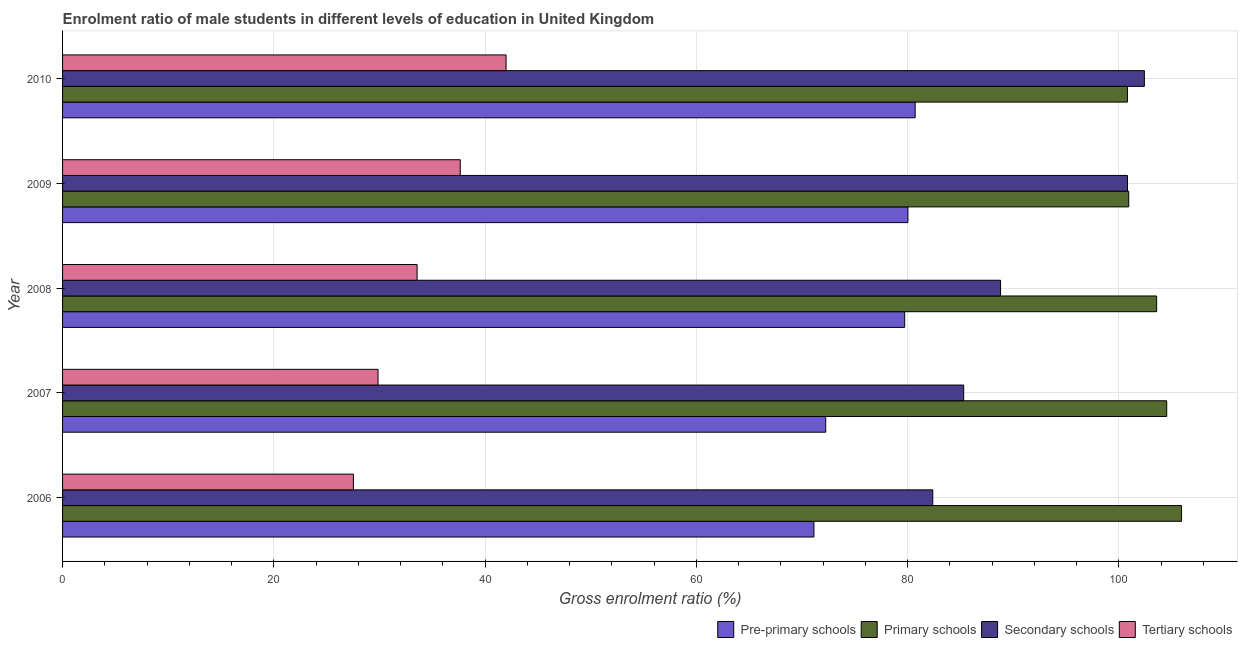How many bars are there on the 1st tick from the bottom?
Your answer should be compact. 4. What is the label of the 2nd group of bars from the top?
Make the answer very short. 2009. In how many cases, is the number of bars for a given year not equal to the number of legend labels?
Provide a succinct answer. 0. What is the gross enrolment ratio(female) in primary schools in 2008?
Your answer should be very brief. 103.57. Across all years, what is the maximum gross enrolment ratio(female) in tertiary schools?
Your answer should be very brief. 41.98. Across all years, what is the minimum gross enrolment ratio(female) in tertiary schools?
Provide a short and direct response. 27.53. In which year was the gross enrolment ratio(female) in primary schools maximum?
Provide a succinct answer. 2006. In which year was the gross enrolment ratio(female) in primary schools minimum?
Provide a short and direct response. 2010. What is the total gross enrolment ratio(female) in primary schools in the graph?
Your response must be concise. 515.78. What is the difference between the gross enrolment ratio(female) in secondary schools in 2008 and that in 2010?
Provide a succinct answer. -13.61. What is the difference between the gross enrolment ratio(female) in tertiary schools in 2010 and the gross enrolment ratio(female) in pre-primary schools in 2009?
Offer a terse response. -38.05. What is the average gross enrolment ratio(female) in tertiary schools per year?
Ensure brevity in your answer.  34.12. In the year 2010, what is the difference between the gross enrolment ratio(female) in secondary schools and gross enrolment ratio(female) in primary schools?
Provide a succinct answer. 1.6. In how many years, is the gross enrolment ratio(female) in pre-primary schools greater than 16 %?
Give a very brief answer. 5. What is the ratio of the gross enrolment ratio(female) in pre-primary schools in 2007 to that in 2010?
Provide a succinct answer. 0.9. Is the gross enrolment ratio(female) in secondary schools in 2006 less than that in 2008?
Your response must be concise. Yes. What is the difference between the highest and the second highest gross enrolment ratio(female) in primary schools?
Offer a very short reply. 1.41. What is the difference between the highest and the lowest gross enrolment ratio(female) in tertiary schools?
Your response must be concise. 14.45. Is it the case that in every year, the sum of the gross enrolment ratio(female) in secondary schools and gross enrolment ratio(female) in pre-primary schools is greater than the sum of gross enrolment ratio(female) in tertiary schools and gross enrolment ratio(female) in primary schools?
Your answer should be compact. No. What does the 3rd bar from the top in 2010 represents?
Give a very brief answer. Primary schools. What does the 3rd bar from the bottom in 2009 represents?
Offer a very short reply. Secondary schools. Is it the case that in every year, the sum of the gross enrolment ratio(female) in pre-primary schools and gross enrolment ratio(female) in primary schools is greater than the gross enrolment ratio(female) in secondary schools?
Provide a short and direct response. Yes. How many bars are there?
Provide a succinct answer. 20. Are all the bars in the graph horizontal?
Ensure brevity in your answer.  Yes. What is the difference between two consecutive major ticks on the X-axis?
Your answer should be compact. 20. Does the graph contain any zero values?
Keep it short and to the point. No. Does the graph contain grids?
Offer a very short reply. Yes. How many legend labels are there?
Offer a terse response. 4. What is the title of the graph?
Give a very brief answer. Enrolment ratio of male students in different levels of education in United Kingdom. What is the label or title of the Y-axis?
Offer a terse response. Year. What is the Gross enrolment ratio (%) of Pre-primary schools in 2006?
Your answer should be compact. 71.13. What is the Gross enrolment ratio (%) of Primary schools in 2006?
Keep it short and to the point. 105.93. What is the Gross enrolment ratio (%) in Secondary schools in 2006?
Keep it short and to the point. 82.38. What is the Gross enrolment ratio (%) of Tertiary schools in 2006?
Your response must be concise. 27.53. What is the Gross enrolment ratio (%) of Pre-primary schools in 2007?
Offer a very short reply. 72.25. What is the Gross enrolment ratio (%) of Primary schools in 2007?
Your response must be concise. 104.53. What is the Gross enrolment ratio (%) in Secondary schools in 2007?
Your response must be concise. 85.31. What is the Gross enrolment ratio (%) of Tertiary schools in 2007?
Offer a terse response. 29.87. What is the Gross enrolment ratio (%) in Pre-primary schools in 2008?
Make the answer very short. 79.72. What is the Gross enrolment ratio (%) in Primary schools in 2008?
Provide a short and direct response. 103.57. What is the Gross enrolment ratio (%) in Secondary schools in 2008?
Your response must be concise. 88.8. What is the Gross enrolment ratio (%) of Tertiary schools in 2008?
Your answer should be compact. 33.56. What is the Gross enrolment ratio (%) of Pre-primary schools in 2009?
Give a very brief answer. 80.03. What is the Gross enrolment ratio (%) of Primary schools in 2009?
Provide a short and direct response. 100.93. What is the Gross enrolment ratio (%) of Secondary schools in 2009?
Offer a very short reply. 100.82. What is the Gross enrolment ratio (%) in Tertiary schools in 2009?
Offer a very short reply. 37.65. What is the Gross enrolment ratio (%) of Pre-primary schools in 2010?
Ensure brevity in your answer.  80.71. What is the Gross enrolment ratio (%) in Primary schools in 2010?
Provide a short and direct response. 100.81. What is the Gross enrolment ratio (%) in Secondary schools in 2010?
Give a very brief answer. 102.41. What is the Gross enrolment ratio (%) in Tertiary schools in 2010?
Make the answer very short. 41.98. Across all years, what is the maximum Gross enrolment ratio (%) of Pre-primary schools?
Offer a terse response. 80.71. Across all years, what is the maximum Gross enrolment ratio (%) of Primary schools?
Give a very brief answer. 105.93. Across all years, what is the maximum Gross enrolment ratio (%) in Secondary schools?
Offer a very short reply. 102.41. Across all years, what is the maximum Gross enrolment ratio (%) of Tertiary schools?
Provide a succinct answer. 41.98. Across all years, what is the minimum Gross enrolment ratio (%) in Pre-primary schools?
Provide a short and direct response. 71.13. Across all years, what is the minimum Gross enrolment ratio (%) in Primary schools?
Your answer should be compact. 100.81. Across all years, what is the minimum Gross enrolment ratio (%) in Secondary schools?
Provide a short and direct response. 82.38. Across all years, what is the minimum Gross enrolment ratio (%) of Tertiary schools?
Your answer should be compact. 27.53. What is the total Gross enrolment ratio (%) in Pre-primary schools in the graph?
Your response must be concise. 383.84. What is the total Gross enrolment ratio (%) in Primary schools in the graph?
Ensure brevity in your answer.  515.78. What is the total Gross enrolment ratio (%) of Secondary schools in the graph?
Provide a succinct answer. 459.72. What is the total Gross enrolment ratio (%) in Tertiary schools in the graph?
Make the answer very short. 170.59. What is the difference between the Gross enrolment ratio (%) in Pre-primary schools in 2006 and that in 2007?
Your answer should be compact. -1.11. What is the difference between the Gross enrolment ratio (%) in Primary schools in 2006 and that in 2007?
Provide a short and direct response. 1.41. What is the difference between the Gross enrolment ratio (%) in Secondary schools in 2006 and that in 2007?
Your answer should be very brief. -2.93. What is the difference between the Gross enrolment ratio (%) of Tertiary schools in 2006 and that in 2007?
Keep it short and to the point. -2.33. What is the difference between the Gross enrolment ratio (%) of Pre-primary schools in 2006 and that in 2008?
Offer a very short reply. -8.59. What is the difference between the Gross enrolment ratio (%) in Primary schools in 2006 and that in 2008?
Ensure brevity in your answer.  2.36. What is the difference between the Gross enrolment ratio (%) of Secondary schools in 2006 and that in 2008?
Provide a succinct answer. -6.42. What is the difference between the Gross enrolment ratio (%) of Tertiary schools in 2006 and that in 2008?
Your answer should be very brief. -6.03. What is the difference between the Gross enrolment ratio (%) in Pre-primary schools in 2006 and that in 2009?
Offer a very short reply. -8.9. What is the difference between the Gross enrolment ratio (%) of Primary schools in 2006 and that in 2009?
Offer a very short reply. 5. What is the difference between the Gross enrolment ratio (%) of Secondary schools in 2006 and that in 2009?
Give a very brief answer. -18.43. What is the difference between the Gross enrolment ratio (%) of Tertiary schools in 2006 and that in 2009?
Ensure brevity in your answer.  -10.12. What is the difference between the Gross enrolment ratio (%) in Pre-primary schools in 2006 and that in 2010?
Give a very brief answer. -9.58. What is the difference between the Gross enrolment ratio (%) in Primary schools in 2006 and that in 2010?
Provide a short and direct response. 5.12. What is the difference between the Gross enrolment ratio (%) of Secondary schools in 2006 and that in 2010?
Your answer should be very brief. -20.03. What is the difference between the Gross enrolment ratio (%) of Tertiary schools in 2006 and that in 2010?
Your answer should be very brief. -14.45. What is the difference between the Gross enrolment ratio (%) of Pre-primary schools in 2007 and that in 2008?
Provide a succinct answer. -7.48. What is the difference between the Gross enrolment ratio (%) of Primary schools in 2007 and that in 2008?
Ensure brevity in your answer.  0.95. What is the difference between the Gross enrolment ratio (%) of Secondary schools in 2007 and that in 2008?
Your answer should be compact. -3.49. What is the difference between the Gross enrolment ratio (%) of Tertiary schools in 2007 and that in 2008?
Your response must be concise. -3.7. What is the difference between the Gross enrolment ratio (%) of Pre-primary schools in 2007 and that in 2009?
Your answer should be compact. -7.79. What is the difference between the Gross enrolment ratio (%) of Primary schools in 2007 and that in 2009?
Ensure brevity in your answer.  3.59. What is the difference between the Gross enrolment ratio (%) of Secondary schools in 2007 and that in 2009?
Ensure brevity in your answer.  -15.51. What is the difference between the Gross enrolment ratio (%) of Tertiary schools in 2007 and that in 2009?
Make the answer very short. -7.78. What is the difference between the Gross enrolment ratio (%) of Pre-primary schools in 2007 and that in 2010?
Give a very brief answer. -8.47. What is the difference between the Gross enrolment ratio (%) of Primary schools in 2007 and that in 2010?
Provide a short and direct response. 3.72. What is the difference between the Gross enrolment ratio (%) of Secondary schools in 2007 and that in 2010?
Offer a terse response. -17.11. What is the difference between the Gross enrolment ratio (%) in Tertiary schools in 2007 and that in 2010?
Your response must be concise. -12.12. What is the difference between the Gross enrolment ratio (%) in Pre-primary schools in 2008 and that in 2009?
Your answer should be very brief. -0.31. What is the difference between the Gross enrolment ratio (%) of Primary schools in 2008 and that in 2009?
Provide a succinct answer. 2.64. What is the difference between the Gross enrolment ratio (%) of Secondary schools in 2008 and that in 2009?
Offer a terse response. -12.02. What is the difference between the Gross enrolment ratio (%) in Tertiary schools in 2008 and that in 2009?
Your answer should be compact. -4.08. What is the difference between the Gross enrolment ratio (%) of Pre-primary schools in 2008 and that in 2010?
Make the answer very short. -0.99. What is the difference between the Gross enrolment ratio (%) in Primary schools in 2008 and that in 2010?
Your answer should be compact. 2.77. What is the difference between the Gross enrolment ratio (%) of Secondary schools in 2008 and that in 2010?
Offer a very short reply. -13.61. What is the difference between the Gross enrolment ratio (%) in Tertiary schools in 2008 and that in 2010?
Offer a very short reply. -8.42. What is the difference between the Gross enrolment ratio (%) of Pre-primary schools in 2009 and that in 2010?
Offer a terse response. -0.68. What is the difference between the Gross enrolment ratio (%) of Primary schools in 2009 and that in 2010?
Make the answer very short. 0.13. What is the difference between the Gross enrolment ratio (%) in Secondary schools in 2009 and that in 2010?
Offer a terse response. -1.6. What is the difference between the Gross enrolment ratio (%) in Tertiary schools in 2009 and that in 2010?
Offer a terse response. -4.34. What is the difference between the Gross enrolment ratio (%) in Pre-primary schools in 2006 and the Gross enrolment ratio (%) in Primary schools in 2007?
Make the answer very short. -33.4. What is the difference between the Gross enrolment ratio (%) in Pre-primary schools in 2006 and the Gross enrolment ratio (%) in Secondary schools in 2007?
Provide a short and direct response. -14.18. What is the difference between the Gross enrolment ratio (%) in Pre-primary schools in 2006 and the Gross enrolment ratio (%) in Tertiary schools in 2007?
Ensure brevity in your answer.  41.27. What is the difference between the Gross enrolment ratio (%) of Primary schools in 2006 and the Gross enrolment ratio (%) of Secondary schools in 2007?
Your answer should be very brief. 20.62. What is the difference between the Gross enrolment ratio (%) in Primary schools in 2006 and the Gross enrolment ratio (%) in Tertiary schools in 2007?
Offer a very short reply. 76.07. What is the difference between the Gross enrolment ratio (%) in Secondary schools in 2006 and the Gross enrolment ratio (%) in Tertiary schools in 2007?
Your answer should be compact. 52.52. What is the difference between the Gross enrolment ratio (%) of Pre-primary schools in 2006 and the Gross enrolment ratio (%) of Primary schools in 2008?
Make the answer very short. -32.44. What is the difference between the Gross enrolment ratio (%) in Pre-primary schools in 2006 and the Gross enrolment ratio (%) in Secondary schools in 2008?
Give a very brief answer. -17.67. What is the difference between the Gross enrolment ratio (%) in Pre-primary schools in 2006 and the Gross enrolment ratio (%) in Tertiary schools in 2008?
Your response must be concise. 37.57. What is the difference between the Gross enrolment ratio (%) in Primary schools in 2006 and the Gross enrolment ratio (%) in Secondary schools in 2008?
Your answer should be very brief. 17.13. What is the difference between the Gross enrolment ratio (%) in Primary schools in 2006 and the Gross enrolment ratio (%) in Tertiary schools in 2008?
Provide a short and direct response. 72.37. What is the difference between the Gross enrolment ratio (%) of Secondary schools in 2006 and the Gross enrolment ratio (%) of Tertiary schools in 2008?
Keep it short and to the point. 48.82. What is the difference between the Gross enrolment ratio (%) of Pre-primary schools in 2006 and the Gross enrolment ratio (%) of Primary schools in 2009?
Offer a terse response. -29.8. What is the difference between the Gross enrolment ratio (%) in Pre-primary schools in 2006 and the Gross enrolment ratio (%) in Secondary schools in 2009?
Offer a very short reply. -29.68. What is the difference between the Gross enrolment ratio (%) of Pre-primary schools in 2006 and the Gross enrolment ratio (%) of Tertiary schools in 2009?
Offer a terse response. 33.48. What is the difference between the Gross enrolment ratio (%) in Primary schools in 2006 and the Gross enrolment ratio (%) in Secondary schools in 2009?
Your answer should be very brief. 5.12. What is the difference between the Gross enrolment ratio (%) in Primary schools in 2006 and the Gross enrolment ratio (%) in Tertiary schools in 2009?
Give a very brief answer. 68.28. What is the difference between the Gross enrolment ratio (%) in Secondary schools in 2006 and the Gross enrolment ratio (%) in Tertiary schools in 2009?
Make the answer very short. 44.73. What is the difference between the Gross enrolment ratio (%) of Pre-primary schools in 2006 and the Gross enrolment ratio (%) of Primary schools in 2010?
Give a very brief answer. -29.68. What is the difference between the Gross enrolment ratio (%) in Pre-primary schools in 2006 and the Gross enrolment ratio (%) in Secondary schools in 2010?
Your answer should be very brief. -31.28. What is the difference between the Gross enrolment ratio (%) of Pre-primary schools in 2006 and the Gross enrolment ratio (%) of Tertiary schools in 2010?
Give a very brief answer. 29.15. What is the difference between the Gross enrolment ratio (%) of Primary schools in 2006 and the Gross enrolment ratio (%) of Secondary schools in 2010?
Provide a short and direct response. 3.52. What is the difference between the Gross enrolment ratio (%) in Primary schools in 2006 and the Gross enrolment ratio (%) in Tertiary schools in 2010?
Make the answer very short. 63.95. What is the difference between the Gross enrolment ratio (%) in Secondary schools in 2006 and the Gross enrolment ratio (%) in Tertiary schools in 2010?
Make the answer very short. 40.4. What is the difference between the Gross enrolment ratio (%) of Pre-primary schools in 2007 and the Gross enrolment ratio (%) of Primary schools in 2008?
Your answer should be very brief. -31.33. What is the difference between the Gross enrolment ratio (%) in Pre-primary schools in 2007 and the Gross enrolment ratio (%) in Secondary schools in 2008?
Make the answer very short. -16.55. What is the difference between the Gross enrolment ratio (%) of Pre-primary schools in 2007 and the Gross enrolment ratio (%) of Tertiary schools in 2008?
Give a very brief answer. 38.68. What is the difference between the Gross enrolment ratio (%) of Primary schools in 2007 and the Gross enrolment ratio (%) of Secondary schools in 2008?
Your answer should be very brief. 15.73. What is the difference between the Gross enrolment ratio (%) of Primary schools in 2007 and the Gross enrolment ratio (%) of Tertiary schools in 2008?
Offer a very short reply. 70.96. What is the difference between the Gross enrolment ratio (%) in Secondary schools in 2007 and the Gross enrolment ratio (%) in Tertiary schools in 2008?
Provide a succinct answer. 51.75. What is the difference between the Gross enrolment ratio (%) in Pre-primary schools in 2007 and the Gross enrolment ratio (%) in Primary schools in 2009?
Your answer should be compact. -28.69. What is the difference between the Gross enrolment ratio (%) in Pre-primary schools in 2007 and the Gross enrolment ratio (%) in Secondary schools in 2009?
Ensure brevity in your answer.  -28.57. What is the difference between the Gross enrolment ratio (%) in Pre-primary schools in 2007 and the Gross enrolment ratio (%) in Tertiary schools in 2009?
Provide a succinct answer. 34.6. What is the difference between the Gross enrolment ratio (%) in Primary schools in 2007 and the Gross enrolment ratio (%) in Secondary schools in 2009?
Your response must be concise. 3.71. What is the difference between the Gross enrolment ratio (%) of Primary schools in 2007 and the Gross enrolment ratio (%) of Tertiary schools in 2009?
Ensure brevity in your answer.  66.88. What is the difference between the Gross enrolment ratio (%) of Secondary schools in 2007 and the Gross enrolment ratio (%) of Tertiary schools in 2009?
Offer a very short reply. 47.66. What is the difference between the Gross enrolment ratio (%) of Pre-primary schools in 2007 and the Gross enrolment ratio (%) of Primary schools in 2010?
Make the answer very short. -28.56. What is the difference between the Gross enrolment ratio (%) in Pre-primary schools in 2007 and the Gross enrolment ratio (%) in Secondary schools in 2010?
Ensure brevity in your answer.  -30.17. What is the difference between the Gross enrolment ratio (%) in Pre-primary schools in 2007 and the Gross enrolment ratio (%) in Tertiary schools in 2010?
Keep it short and to the point. 30.26. What is the difference between the Gross enrolment ratio (%) of Primary schools in 2007 and the Gross enrolment ratio (%) of Secondary schools in 2010?
Keep it short and to the point. 2.11. What is the difference between the Gross enrolment ratio (%) of Primary schools in 2007 and the Gross enrolment ratio (%) of Tertiary schools in 2010?
Offer a very short reply. 62.54. What is the difference between the Gross enrolment ratio (%) in Secondary schools in 2007 and the Gross enrolment ratio (%) in Tertiary schools in 2010?
Your answer should be compact. 43.32. What is the difference between the Gross enrolment ratio (%) in Pre-primary schools in 2008 and the Gross enrolment ratio (%) in Primary schools in 2009?
Provide a succinct answer. -21.21. What is the difference between the Gross enrolment ratio (%) in Pre-primary schools in 2008 and the Gross enrolment ratio (%) in Secondary schools in 2009?
Ensure brevity in your answer.  -21.09. What is the difference between the Gross enrolment ratio (%) of Pre-primary schools in 2008 and the Gross enrolment ratio (%) of Tertiary schools in 2009?
Keep it short and to the point. 42.07. What is the difference between the Gross enrolment ratio (%) in Primary schools in 2008 and the Gross enrolment ratio (%) in Secondary schools in 2009?
Offer a terse response. 2.76. What is the difference between the Gross enrolment ratio (%) of Primary schools in 2008 and the Gross enrolment ratio (%) of Tertiary schools in 2009?
Ensure brevity in your answer.  65.93. What is the difference between the Gross enrolment ratio (%) of Secondary schools in 2008 and the Gross enrolment ratio (%) of Tertiary schools in 2009?
Your answer should be very brief. 51.15. What is the difference between the Gross enrolment ratio (%) in Pre-primary schools in 2008 and the Gross enrolment ratio (%) in Primary schools in 2010?
Keep it short and to the point. -21.09. What is the difference between the Gross enrolment ratio (%) of Pre-primary schools in 2008 and the Gross enrolment ratio (%) of Secondary schools in 2010?
Keep it short and to the point. -22.69. What is the difference between the Gross enrolment ratio (%) of Pre-primary schools in 2008 and the Gross enrolment ratio (%) of Tertiary schools in 2010?
Provide a succinct answer. 37.74. What is the difference between the Gross enrolment ratio (%) in Primary schools in 2008 and the Gross enrolment ratio (%) in Secondary schools in 2010?
Provide a succinct answer. 1.16. What is the difference between the Gross enrolment ratio (%) in Primary schools in 2008 and the Gross enrolment ratio (%) in Tertiary schools in 2010?
Keep it short and to the point. 61.59. What is the difference between the Gross enrolment ratio (%) of Secondary schools in 2008 and the Gross enrolment ratio (%) of Tertiary schools in 2010?
Ensure brevity in your answer.  46.81. What is the difference between the Gross enrolment ratio (%) in Pre-primary schools in 2009 and the Gross enrolment ratio (%) in Primary schools in 2010?
Your answer should be very brief. -20.78. What is the difference between the Gross enrolment ratio (%) in Pre-primary schools in 2009 and the Gross enrolment ratio (%) in Secondary schools in 2010?
Provide a short and direct response. -22.38. What is the difference between the Gross enrolment ratio (%) of Pre-primary schools in 2009 and the Gross enrolment ratio (%) of Tertiary schools in 2010?
Your answer should be very brief. 38.05. What is the difference between the Gross enrolment ratio (%) in Primary schools in 2009 and the Gross enrolment ratio (%) in Secondary schools in 2010?
Ensure brevity in your answer.  -1.48. What is the difference between the Gross enrolment ratio (%) of Primary schools in 2009 and the Gross enrolment ratio (%) of Tertiary schools in 2010?
Offer a terse response. 58.95. What is the difference between the Gross enrolment ratio (%) in Secondary schools in 2009 and the Gross enrolment ratio (%) in Tertiary schools in 2010?
Offer a terse response. 58.83. What is the average Gross enrolment ratio (%) in Pre-primary schools per year?
Your response must be concise. 76.77. What is the average Gross enrolment ratio (%) of Primary schools per year?
Make the answer very short. 103.16. What is the average Gross enrolment ratio (%) of Secondary schools per year?
Make the answer very short. 91.94. What is the average Gross enrolment ratio (%) in Tertiary schools per year?
Provide a short and direct response. 34.12. In the year 2006, what is the difference between the Gross enrolment ratio (%) in Pre-primary schools and Gross enrolment ratio (%) in Primary schools?
Keep it short and to the point. -34.8. In the year 2006, what is the difference between the Gross enrolment ratio (%) of Pre-primary schools and Gross enrolment ratio (%) of Secondary schools?
Give a very brief answer. -11.25. In the year 2006, what is the difference between the Gross enrolment ratio (%) of Pre-primary schools and Gross enrolment ratio (%) of Tertiary schools?
Offer a terse response. 43.6. In the year 2006, what is the difference between the Gross enrolment ratio (%) in Primary schools and Gross enrolment ratio (%) in Secondary schools?
Keep it short and to the point. 23.55. In the year 2006, what is the difference between the Gross enrolment ratio (%) of Primary schools and Gross enrolment ratio (%) of Tertiary schools?
Make the answer very short. 78.4. In the year 2006, what is the difference between the Gross enrolment ratio (%) in Secondary schools and Gross enrolment ratio (%) in Tertiary schools?
Keep it short and to the point. 54.85. In the year 2007, what is the difference between the Gross enrolment ratio (%) in Pre-primary schools and Gross enrolment ratio (%) in Primary schools?
Keep it short and to the point. -32.28. In the year 2007, what is the difference between the Gross enrolment ratio (%) of Pre-primary schools and Gross enrolment ratio (%) of Secondary schools?
Offer a very short reply. -13.06. In the year 2007, what is the difference between the Gross enrolment ratio (%) of Pre-primary schools and Gross enrolment ratio (%) of Tertiary schools?
Keep it short and to the point. 42.38. In the year 2007, what is the difference between the Gross enrolment ratio (%) of Primary schools and Gross enrolment ratio (%) of Secondary schools?
Offer a terse response. 19.22. In the year 2007, what is the difference between the Gross enrolment ratio (%) of Primary schools and Gross enrolment ratio (%) of Tertiary schools?
Your response must be concise. 74.66. In the year 2007, what is the difference between the Gross enrolment ratio (%) in Secondary schools and Gross enrolment ratio (%) in Tertiary schools?
Give a very brief answer. 55.44. In the year 2008, what is the difference between the Gross enrolment ratio (%) of Pre-primary schools and Gross enrolment ratio (%) of Primary schools?
Provide a succinct answer. -23.85. In the year 2008, what is the difference between the Gross enrolment ratio (%) in Pre-primary schools and Gross enrolment ratio (%) in Secondary schools?
Keep it short and to the point. -9.08. In the year 2008, what is the difference between the Gross enrolment ratio (%) in Pre-primary schools and Gross enrolment ratio (%) in Tertiary schools?
Offer a terse response. 46.16. In the year 2008, what is the difference between the Gross enrolment ratio (%) of Primary schools and Gross enrolment ratio (%) of Secondary schools?
Your answer should be compact. 14.78. In the year 2008, what is the difference between the Gross enrolment ratio (%) in Primary schools and Gross enrolment ratio (%) in Tertiary schools?
Keep it short and to the point. 70.01. In the year 2008, what is the difference between the Gross enrolment ratio (%) in Secondary schools and Gross enrolment ratio (%) in Tertiary schools?
Provide a short and direct response. 55.24. In the year 2009, what is the difference between the Gross enrolment ratio (%) of Pre-primary schools and Gross enrolment ratio (%) of Primary schools?
Make the answer very short. -20.9. In the year 2009, what is the difference between the Gross enrolment ratio (%) of Pre-primary schools and Gross enrolment ratio (%) of Secondary schools?
Provide a short and direct response. -20.78. In the year 2009, what is the difference between the Gross enrolment ratio (%) of Pre-primary schools and Gross enrolment ratio (%) of Tertiary schools?
Your answer should be compact. 42.38. In the year 2009, what is the difference between the Gross enrolment ratio (%) of Primary schools and Gross enrolment ratio (%) of Secondary schools?
Your response must be concise. 0.12. In the year 2009, what is the difference between the Gross enrolment ratio (%) of Primary schools and Gross enrolment ratio (%) of Tertiary schools?
Your answer should be compact. 63.29. In the year 2009, what is the difference between the Gross enrolment ratio (%) of Secondary schools and Gross enrolment ratio (%) of Tertiary schools?
Ensure brevity in your answer.  63.17. In the year 2010, what is the difference between the Gross enrolment ratio (%) of Pre-primary schools and Gross enrolment ratio (%) of Primary schools?
Your answer should be compact. -20.09. In the year 2010, what is the difference between the Gross enrolment ratio (%) of Pre-primary schools and Gross enrolment ratio (%) of Secondary schools?
Your answer should be very brief. -21.7. In the year 2010, what is the difference between the Gross enrolment ratio (%) in Pre-primary schools and Gross enrolment ratio (%) in Tertiary schools?
Your response must be concise. 38.73. In the year 2010, what is the difference between the Gross enrolment ratio (%) of Primary schools and Gross enrolment ratio (%) of Secondary schools?
Provide a succinct answer. -1.61. In the year 2010, what is the difference between the Gross enrolment ratio (%) of Primary schools and Gross enrolment ratio (%) of Tertiary schools?
Make the answer very short. 58.82. In the year 2010, what is the difference between the Gross enrolment ratio (%) of Secondary schools and Gross enrolment ratio (%) of Tertiary schools?
Your answer should be very brief. 60.43. What is the ratio of the Gross enrolment ratio (%) in Pre-primary schools in 2006 to that in 2007?
Your answer should be compact. 0.98. What is the ratio of the Gross enrolment ratio (%) in Primary schools in 2006 to that in 2007?
Offer a very short reply. 1.01. What is the ratio of the Gross enrolment ratio (%) of Secondary schools in 2006 to that in 2007?
Offer a very short reply. 0.97. What is the ratio of the Gross enrolment ratio (%) in Tertiary schools in 2006 to that in 2007?
Provide a short and direct response. 0.92. What is the ratio of the Gross enrolment ratio (%) of Pre-primary schools in 2006 to that in 2008?
Provide a succinct answer. 0.89. What is the ratio of the Gross enrolment ratio (%) of Primary schools in 2006 to that in 2008?
Your answer should be very brief. 1.02. What is the ratio of the Gross enrolment ratio (%) in Secondary schools in 2006 to that in 2008?
Give a very brief answer. 0.93. What is the ratio of the Gross enrolment ratio (%) of Tertiary schools in 2006 to that in 2008?
Ensure brevity in your answer.  0.82. What is the ratio of the Gross enrolment ratio (%) of Pre-primary schools in 2006 to that in 2009?
Make the answer very short. 0.89. What is the ratio of the Gross enrolment ratio (%) of Primary schools in 2006 to that in 2009?
Keep it short and to the point. 1.05. What is the ratio of the Gross enrolment ratio (%) of Secondary schools in 2006 to that in 2009?
Keep it short and to the point. 0.82. What is the ratio of the Gross enrolment ratio (%) of Tertiary schools in 2006 to that in 2009?
Give a very brief answer. 0.73. What is the ratio of the Gross enrolment ratio (%) of Pre-primary schools in 2006 to that in 2010?
Your response must be concise. 0.88. What is the ratio of the Gross enrolment ratio (%) in Primary schools in 2006 to that in 2010?
Your answer should be compact. 1.05. What is the ratio of the Gross enrolment ratio (%) of Secondary schools in 2006 to that in 2010?
Provide a succinct answer. 0.8. What is the ratio of the Gross enrolment ratio (%) in Tertiary schools in 2006 to that in 2010?
Your answer should be compact. 0.66. What is the ratio of the Gross enrolment ratio (%) of Pre-primary schools in 2007 to that in 2008?
Provide a succinct answer. 0.91. What is the ratio of the Gross enrolment ratio (%) in Primary schools in 2007 to that in 2008?
Provide a short and direct response. 1.01. What is the ratio of the Gross enrolment ratio (%) in Secondary schools in 2007 to that in 2008?
Ensure brevity in your answer.  0.96. What is the ratio of the Gross enrolment ratio (%) in Tertiary schools in 2007 to that in 2008?
Provide a short and direct response. 0.89. What is the ratio of the Gross enrolment ratio (%) of Pre-primary schools in 2007 to that in 2009?
Ensure brevity in your answer.  0.9. What is the ratio of the Gross enrolment ratio (%) of Primary schools in 2007 to that in 2009?
Ensure brevity in your answer.  1.04. What is the ratio of the Gross enrolment ratio (%) of Secondary schools in 2007 to that in 2009?
Your answer should be compact. 0.85. What is the ratio of the Gross enrolment ratio (%) in Tertiary schools in 2007 to that in 2009?
Give a very brief answer. 0.79. What is the ratio of the Gross enrolment ratio (%) in Pre-primary schools in 2007 to that in 2010?
Ensure brevity in your answer.  0.9. What is the ratio of the Gross enrolment ratio (%) of Primary schools in 2007 to that in 2010?
Keep it short and to the point. 1.04. What is the ratio of the Gross enrolment ratio (%) of Secondary schools in 2007 to that in 2010?
Your answer should be very brief. 0.83. What is the ratio of the Gross enrolment ratio (%) of Tertiary schools in 2007 to that in 2010?
Give a very brief answer. 0.71. What is the ratio of the Gross enrolment ratio (%) in Primary schools in 2008 to that in 2009?
Your answer should be compact. 1.03. What is the ratio of the Gross enrolment ratio (%) in Secondary schools in 2008 to that in 2009?
Offer a very short reply. 0.88. What is the ratio of the Gross enrolment ratio (%) of Tertiary schools in 2008 to that in 2009?
Your response must be concise. 0.89. What is the ratio of the Gross enrolment ratio (%) of Pre-primary schools in 2008 to that in 2010?
Your answer should be compact. 0.99. What is the ratio of the Gross enrolment ratio (%) of Primary schools in 2008 to that in 2010?
Keep it short and to the point. 1.03. What is the ratio of the Gross enrolment ratio (%) in Secondary schools in 2008 to that in 2010?
Provide a short and direct response. 0.87. What is the ratio of the Gross enrolment ratio (%) in Tertiary schools in 2008 to that in 2010?
Provide a succinct answer. 0.8. What is the ratio of the Gross enrolment ratio (%) of Secondary schools in 2009 to that in 2010?
Your response must be concise. 0.98. What is the ratio of the Gross enrolment ratio (%) in Tertiary schools in 2009 to that in 2010?
Give a very brief answer. 0.9. What is the difference between the highest and the second highest Gross enrolment ratio (%) in Pre-primary schools?
Your answer should be compact. 0.68. What is the difference between the highest and the second highest Gross enrolment ratio (%) of Primary schools?
Your answer should be very brief. 1.41. What is the difference between the highest and the second highest Gross enrolment ratio (%) in Secondary schools?
Offer a very short reply. 1.6. What is the difference between the highest and the second highest Gross enrolment ratio (%) in Tertiary schools?
Your response must be concise. 4.34. What is the difference between the highest and the lowest Gross enrolment ratio (%) of Pre-primary schools?
Offer a very short reply. 9.58. What is the difference between the highest and the lowest Gross enrolment ratio (%) in Primary schools?
Ensure brevity in your answer.  5.12. What is the difference between the highest and the lowest Gross enrolment ratio (%) in Secondary schools?
Your answer should be compact. 20.03. What is the difference between the highest and the lowest Gross enrolment ratio (%) in Tertiary schools?
Make the answer very short. 14.45. 